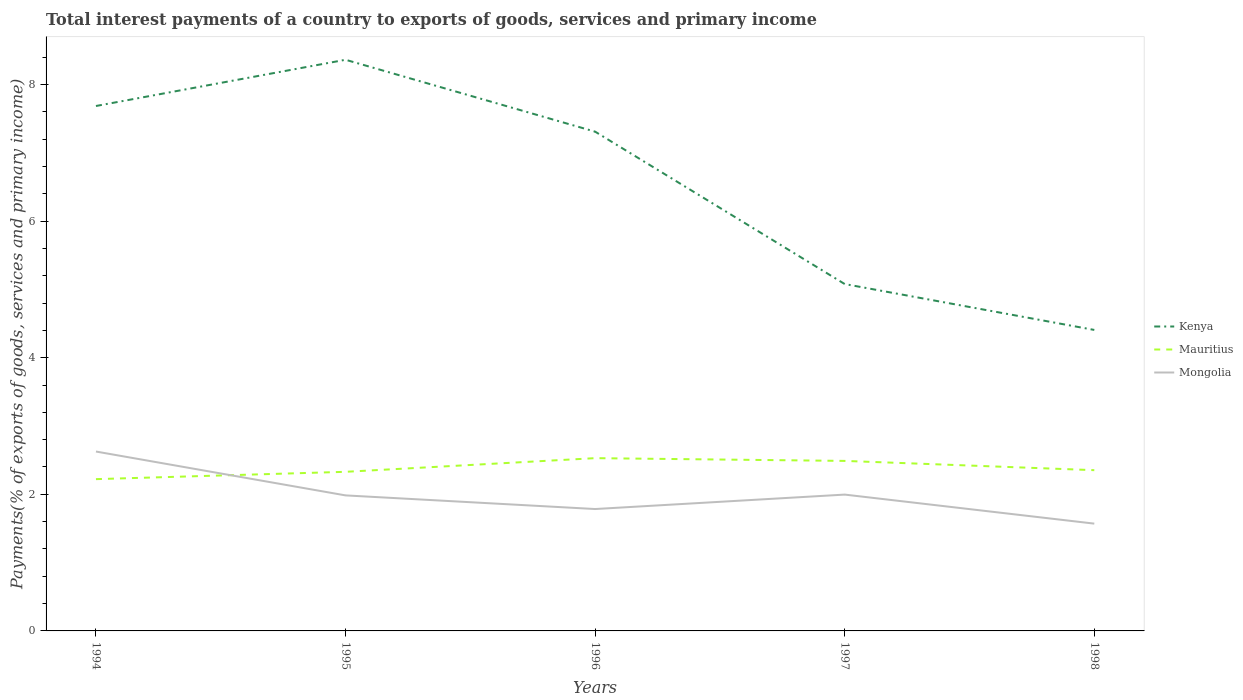How many different coloured lines are there?
Your answer should be very brief. 3. Across all years, what is the maximum total interest payments in Kenya?
Your answer should be very brief. 4.41. In which year was the total interest payments in Mauritius maximum?
Offer a very short reply. 1994. What is the total total interest payments in Kenya in the graph?
Your answer should be compact. 2.61. What is the difference between the highest and the second highest total interest payments in Kenya?
Your response must be concise. 3.96. Is the total interest payments in Kenya strictly greater than the total interest payments in Mongolia over the years?
Your answer should be compact. No. How many years are there in the graph?
Ensure brevity in your answer.  5. What is the difference between two consecutive major ticks on the Y-axis?
Make the answer very short. 2. Does the graph contain any zero values?
Give a very brief answer. No. What is the title of the graph?
Give a very brief answer. Total interest payments of a country to exports of goods, services and primary income. Does "High income" appear as one of the legend labels in the graph?
Provide a succinct answer. No. What is the label or title of the X-axis?
Your answer should be compact. Years. What is the label or title of the Y-axis?
Your response must be concise. Payments(% of exports of goods, services and primary income). What is the Payments(% of exports of goods, services and primary income) in Kenya in 1994?
Offer a terse response. 7.68. What is the Payments(% of exports of goods, services and primary income) in Mauritius in 1994?
Ensure brevity in your answer.  2.22. What is the Payments(% of exports of goods, services and primary income) in Mongolia in 1994?
Ensure brevity in your answer.  2.63. What is the Payments(% of exports of goods, services and primary income) in Kenya in 1995?
Provide a short and direct response. 8.36. What is the Payments(% of exports of goods, services and primary income) in Mauritius in 1995?
Provide a succinct answer. 2.33. What is the Payments(% of exports of goods, services and primary income) of Mongolia in 1995?
Offer a terse response. 1.98. What is the Payments(% of exports of goods, services and primary income) in Kenya in 1996?
Make the answer very short. 7.31. What is the Payments(% of exports of goods, services and primary income) of Mauritius in 1996?
Offer a very short reply. 2.53. What is the Payments(% of exports of goods, services and primary income) in Mongolia in 1996?
Offer a very short reply. 1.78. What is the Payments(% of exports of goods, services and primary income) of Kenya in 1997?
Your response must be concise. 5.08. What is the Payments(% of exports of goods, services and primary income) of Mauritius in 1997?
Ensure brevity in your answer.  2.49. What is the Payments(% of exports of goods, services and primary income) of Mongolia in 1997?
Make the answer very short. 2. What is the Payments(% of exports of goods, services and primary income) of Kenya in 1998?
Your answer should be very brief. 4.41. What is the Payments(% of exports of goods, services and primary income) in Mauritius in 1998?
Your answer should be very brief. 2.35. What is the Payments(% of exports of goods, services and primary income) in Mongolia in 1998?
Provide a succinct answer. 1.57. Across all years, what is the maximum Payments(% of exports of goods, services and primary income) in Kenya?
Give a very brief answer. 8.36. Across all years, what is the maximum Payments(% of exports of goods, services and primary income) in Mauritius?
Your response must be concise. 2.53. Across all years, what is the maximum Payments(% of exports of goods, services and primary income) in Mongolia?
Ensure brevity in your answer.  2.63. Across all years, what is the minimum Payments(% of exports of goods, services and primary income) in Kenya?
Make the answer very short. 4.41. Across all years, what is the minimum Payments(% of exports of goods, services and primary income) of Mauritius?
Provide a short and direct response. 2.22. Across all years, what is the minimum Payments(% of exports of goods, services and primary income) of Mongolia?
Ensure brevity in your answer.  1.57. What is the total Payments(% of exports of goods, services and primary income) in Kenya in the graph?
Your answer should be compact. 32.84. What is the total Payments(% of exports of goods, services and primary income) in Mauritius in the graph?
Your answer should be compact. 11.92. What is the total Payments(% of exports of goods, services and primary income) in Mongolia in the graph?
Give a very brief answer. 9.96. What is the difference between the Payments(% of exports of goods, services and primary income) of Kenya in 1994 and that in 1995?
Give a very brief answer. -0.68. What is the difference between the Payments(% of exports of goods, services and primary income) in Mauritius in 1994 and that in 1995?
Offer a very short reply. -0.11. What is the difference between the Payments(% of exports of goods, services and primary income) of Mongolia in 1994 and that in 1995?
Offer a very short reply. 0.64. What is the difference between the Payments(% of exports of goods, services and primary income) of Kenya in 1994 and that in 1996?
Offer a very short reply. 0.38. What is the difference between the Payments(% of exports of goods, services and primary income) of Mauritius in 1994 and that in 1996?
Your answer should be compact. -0.31. What is the difference between the Payments(% of exports of goods, services and primary income) of Mongolia in 1994 and that in 1996?
Give a very brief answer. 0.84. What is the difference between the Payments(% of exports of goods, services and primary income) in Kenya in 1994 and that in 1997?
Offer a terse response. 2.61. What is the difference between the Payments(% of exports of goods, services and primary income) in Mauritius in 1994 and that in 1997?
Offer a very short reply. -0.27. What is the difference between the Payments(% of exports of goods, services and primary income) of Mongolia in 1994 and that in 1997?
Your answer should be compact. 0.63. What is the difference between the Payments(% of exports of goods, services and primary income) of Kenya in 1994 and that in 1998?
Make the answer very short. 3.28. What is the difference between the Payments(% of exports of goods, services and primary income) of Mauritius in 1994 and that in 1998?
Offer a terse response. -0.13. What is the difference between the Payments(% of exports of goods, services and primary income) of Mongolia in 1994 and that in 1998?
Provide a succinct answer. 1.06. What is the difference between the Payments(% of exports of goods, services and primary income) in Kenya in 1995 and that in 1996?
Provide a short and direct response. 1.05. What is the difference between the Payments(% of exports of goods, services and primary income) of Mauritius in 1995 and that in 1996?
Give a very brief answer. -0.2. What is the difference between the Payments(% of exports of goods, services and primary income) in Mongolia in 1995 and that in 1996?
Offer a very short reply. 0.2. What is the difference between the Payments(% of exports of goods, services and primary income) of Kenya in 1995 and that in 1997?
Your answer should be compact. 3.28. What is the difference between the Payments(% of exports of goods, services and primary income) of Mauritius in 1995 and that in 1997?
Your answer should be very brief. -0.16. What is the difference between the Payments(% of exports of goods, services and primary income) of Mongolia in 1995 and that in 1997?
Your answer should be compact. -0.01. What is the difference between the Payments(% of exports of goods, services and primary income) of Kenya in 1995 and that in 1998?
Your response must be concise. 3.96. What is the difference between the Payments(% of exports of goods, services and primary income) in Mauritius in 1995 and that in 1998?
Your answer should be very brief. -0.02. What is the difference between the Payments(% of exports of goods, services and primary income) in Mongolia in 1995 and that in 1998?
Keep it short and to the point. 0.41. What is the difference between the Payments(% of exports of goods, services and primary income) of Kenya in 1996 and that in 1997?
Your answer should be very brief. 2.23. What is the difference between the Payments(% of exports of goods, services and primary income) of Mauritius in 1996 and that in 1997?
Make the answer very short. 0.04. What is the difference between the Payments(% of exports of goods, services and primary income) of Mongolia in 1996 and that in 1997?
Provide a succinct answer. -0.21. What is the difference between the Payments(% of exports of goods, services and primary income) in Kenya in 1996 and that in 1998?
Your answer should be compact. 2.9. What is the difference between the Payments(% of exports of goods, services and primary income) in Mauritius in 1996 and that in 1998?
Give a very brief answer. 0.18. What is the difference between the Payments(% of exports of goods, services and primary income) of Mongolia in 1996 and that in 1998?
Your answer should be very brief. 0.21. What is the difference between the Payments(% of exports of goods, services and primary income) of Kenya in 1997 and that in 1998?
Offer a very short reply. 0.67. What is the difference between the Payments(% of exports of goods, services and primary income) in Mauritius in 1997 and that in 1998?
Offer a terse response. 0.14. What is the difference between the Payments(% of exports of goods, services and primary income) of Mongolia in 1997 and that in 1998?
Your answer should be very brief. 0.43. What is the difference between the Payments(% of exports of goods, services and primary income) of Kenya in 1994 and the Payments(% of exports of goods, services and primary income) of Mauritius in 1995?
Offer a very short reply. 5.36. What is the difference between the Payments(% of exports of goods, services and primary income) of Kenya in 1994 and the Payments(% of exports of goods, services and primary income) of Mongolia in 1995?
Give a very brief answer. 5.7. What is the difference between the Payments(% of exports of goods, services and primary income) in Mauritius in 1994 and the Payments(% of exports of goods, services and primary income) in Mongolia in 1995?
Your answer should be compact. 0.24. What is the difference between the Payments(% of exports of goods, services and primary income) of Kenya in 1994 and the Payments(% of exports of goods, services and primary income) of Mauritius in 1996?
Ensure brevity in your answer.  5.16. What is the difference between the Payments(% of exports of goods, services and primary income) in Kenya in 1994 and the Payments(% of exports of goods, services and primary income) in Mongolia in 1996?
Keep it short and to the point. 5.9. What is the difference between the Payments(% of exports of goods, services and primary income) of Mauritius in 1994 and the Payments(% of exports of goods, services and primary income) of Mongolia in 1996?
Make the answer very short. 0.44. What is the difference between the Payments(% of exports of goods, services and primary income) of Kenya in 1994 and the Payments(% of exports of goods, services and primary income) of Mauritius in 1997?
Give a very brief answer. 5.2. What is the difference between the Payments(% of exports of goods, services and primary income) of Kenya in 1994 and the Payments(% of exports of goods, services and primary income) of Mongolia in 1997?
Ensure brevity in your answer.  5.69. What is the difference between the Payments(% of exports of goods, services and primary income) of Mauritius in 1994 and the Payments(% of exports of goods, services and primary income) of Mongolia in 1997?
Provide a succinct answer. 0.23. What is the difference between the Payments(% of exports of goods, services and primary income) in Kenya in 1994 and the Payments(% of exports of goods, services and primary income) in Mauritius in 1998?
Your response must be concise. 5.33. What is the difference between the Payments(% of exports of goods, services and primary income) in Kenya in 1994 and the Payments(% of exports of goods, services and primary income) in Mongolia in 1998?
Keep it short and to the point. 6.11. What is the difference between the Payments(% of exports of goods, services and primary income) of Mauritius in 1994 and the Payments(% of exports of goods, services and primary income) of Mongolia in 1998?
Ensure brevity in your answer.  0.65. What is the difference between the Payments(% of exports of goods, services and primary income) of Kenya in 1995 and the Payments(% of exports of goods, services and primary income) of Mauritius in 1996?
Offer a very short reply. 5.83. What is the difference between the Payments(% of exports of goods, services and primary income) in Kenya in 1995 and the Payments(% of exports of goods, services and primary income) in Mongolia in 1996?
Give a very brief answer. 6.58. What is the difference between the Payments(% of exports of goods, services and primary income) of Mauritius in 1995 and the Payments(% of exports of goods, services and primary income) of Mongolia in 1996?
Your answer should be compact. 0.55. What is the difference between the Payments(% of exports of goods, services and primary income) in Kenya in 1995 and the Payments(% of exports of goods, services and primary income) in Mauritius in 1997?
Your response must be concise. 5.87. What is the difference between the Payments(% of exports of goods, services and primary income) in Kenya in 1995 and the Payments(% of exports of goods, services and primary income) in Mongolia in 1997?
Your response must be concise. 6.37. What is the difference between the Payments(% of exports of goods, services and primary income) in Mauritius in 1995 and the Payments(% of exports of goods, services and primary income) in Mongolia in 1997?
Provide a succinct answer. 0.33. What is the difference between the Payments(% of exports of goods, services and primary income) in Kenya in 1995 and the Payments(% of exports of goods, services and primary income) in Mauritius in 1998?
Make the answer very short. 6.01. What is the difference between the Payments(% of exports of goods, services and primary income) of Kenya in 1995 and the Payments(% of exports of goods, services and primary income) of Mongolia in 1998?
Provide a short and direct response. 6.79. What is the difference between the Payments(% of exports of goods, services and primary income) in Mauritius in 1995 and the Payments(% of exports of goods, services and primary income) in Mongolia in 1998?
Offer a very short reply. 0.76. What is the difference between the Payments(% of exports of goods, services and primary income) of Kenya in 1996 and the Payments(% of exports of goods, services and primary income) of Mauritius in 1997?
Offer a terse response. 4.82. What is the difference between the Payments(% of exports of goods, services and primary income) of Kenya in 1996 and the Payments(% of exports of goods, services and primary income) of Mongolia in 1997?
Offer a very short reply. 5.31. What is the difference between the Payments(% of exports of goods, services and primary income) in Mauritius in 1996 and the Payments(% of exports of goods, services and primary income) in Mongolia in 1997?
Ensure brevity in your answer.  0.53. What is the difference between the Payments(% of exports of goods, services and primary income) in Kenya in 1996 and the Payments(% of exports of goods, services and primary income) in Mauritius in 1998?
Give a very brief answer. 4.96. What is the difference between the Payments(% of exports of goods, services and primary income) of Kenya in 1996 and the Payments(% of exports of goods, services and primary income) of Mongolia in 1998?
Your answer should be compact. 5.74. What is the difference between the Payments(% of exports of goods, services and primary income) in Mauritius in 1996 and the Payments(% of exports of goods, services and primary income) in Mongolia in 1998?
Provide a succinct answer. 0.96. What is the difference between the Payments(% of exports of goods, services and primary income) in Kenya in 1997 and the Payments(% of exports of goods, services and primary income) in Mauritius in 1998?
Your answer should be compact. 2.73. What is the difference between the Payments(% of exports of goods, services and primary income) of Kenya in 1997 and the Payments(% of exports of goods, services and primary income) of Mongolia in 1998?
Offer a very short reply. 3.51. What is the difference between the Payments(% of exports of goods, services and primary income) of Mauritius in 1997 and the Payments(% of exports of goods, services and primary income) of Mongolia in 1998?
Your answer should be very brief. 0.92. What is the average Payments(% of exports of goods, services and primary income) in Kenya per year?
Your answer should be very brief. 6.57. What is the average Payments(% of exports of goods, services and primary income) in Mauritius per year?
Your response must be concise. 2.38. What is the average Payments(% of exports of goods, services and primary income) of Mongolia per year?
Your answer should be compact. 1.99. In the year 1994, what is the difference between the Payments(% of exports of goods, services and primary income) of Kenya and Payments(% of exports of goods, services and primary income) of Mauritius?
Keep it short and to the point. 5.46. In the year 1994, what is the difference between the Payments(% of exports of goods, services and primary income) in Kenya and Payments(% of exports of goods, services and primary income) in Mongolia?
Give a very brief answer. 5.06. In the year 1994, what is the difference between the Payments(% of exports of goods, services and primary income) of Mauritius and Payments(% of exports of goods, services and primary income) of Mongolia?
Provide a succinct answer. -0.4. In the year 1995, what is the difference between the Payments(% of exports of goods, services and primary income) of Kenya and Payments(% of exports of goods, services and primary income) of Mauritius?
Keep it short and to the point. 6.03. In the year 1995, what is the difference between the Payments(% of exports of goods, services and primary income) of Kenya and Payments(% of exports of goods, services and primary income) of Mongolia?
Your answer should be very brief. 6.38. In the year 1995, what is the difference between the Payments(% of exports of goods, services and primary income) of Mauritius and Payments(% of exports of goods, services and primary income) of Mongolia?
Offer a very short reply. 0.35. In the year 1996, what is the difference between the Payments(% of exports of goods, services and primary income) in Kenya and Payments(% of exports of goods, services and primary income) in Mauritius?
Provide a short and direct response. 4.78. In the year 1996, what is the difference between the Payments(% of exports of goods, services and primary income) in Kenya and Payments(% of exports of goods, services and primary income) in Mongolia?
Keep it short and to the point. 5.52. In the year 1996, what is the difference between the Payments(% of exports of goods, services and primary income) of Mauritius and Payments(% of exports of goods, services and primary income) of Mongolia?
Your response must be concise. 0.74. In the year 1997, what is the difference between the Payments(% of exports of goods, services and primary income) of Kenya and Payments(% of exports of goods, services and primary income) of Mauritius?
Keep it short and to the point. 2.59. In the year 1997, what is the difference between the Payments(% of exports of goods, services and primary income) in Kenya and Payments(% of exports of goods, services and primary income) in Mongolia?
Keep it short and to the point. 3.08. In the year 1997, what is the difference between the Payments(% of exports of goods, services and primary income) in Mauritius and Payments(% of exports of goods, services and primary income) in Mongolia?
Offer a very short reply. 0.49. In the year 1998, what is the difference between the Payments(% of exports of goods, services and primary income) of Kenya and Payments(% of exports of goods, services and primary income) of Mauritius?
Provide a succinct answer. 2.05. In the year 1998, what is the difference between the Payments(% of exports of goods, services and primary income) in Kenya and Payments(% of exports of goods, services and primary income) in Mongolia?
Your answer should be very brief. 2.84. In the year 1998, what is the difference between the Payments(% of exports of goods, services and primary income) in Mauritius and Payments(% of exports of goods, services and primary income) in Mongolia?
Your answer should be very brief. 0.78. What is the ratio of the Payments(% of exports of goods, services and primary income) in Kenya in 1994 to that in 1995?
Offer a very short reply. 0.92. What is the ratio of the Payments(% of exports of goods, services and primary income) in Mauritius in 1994 to that in 1995?
Offer a very short reply. 0.95. What is the ratio of the Payments(% of exports of goods, services and primary income) in Mongolia in 1994 to that in 1995?
Keep it short and to the point. 1.32. What is the ratio of the Payments(% of exports of goods, services and primary income) in Kenya in 1994 to that in 1996?
Your response must be concise. 1.05. What is the ratio of the Payments(% of exports of goods, services and primary income) of Mauritius in 1994 to that in 1996?
Provide a short and direct response. 0.88. What is the ratio of the Payments(% of exports of goods, services and primary income) in Mongolia in 1994 to that in 1996?
Your answer should be compact. 1.47. What is the ratio of the Payments(% of exports of goods, services and primary income) in Kenya in 1994 to that in 1997?
Make the answer very short. 1.51. What is the ratio of the Payments(% of exports of goods, services and primary income) in Mauritius in 1994 to that in 1997?
Make the answer very short. 0.89. What is the ratio of the Payments(% of exports of goods, services and primary income) in Mongolia in 1994 to that in 1997?
Keep it short and to the point. 1.32. What is the ratio of the Payments(% of exports of goods, services and primary income) in Kenya in 1994 to that in 1998?
Your response must be concise. 1.74. What is the ratio of the Payments(% of exports of goods, services and primary income) of Mauritius in 1994 to that in 1998?
Your answer should be very brief. 0.94. What is the ratio of the Payments(% of exports of goods, services and primary income) in Mongolia in 1994 to that in 1998?
Offer a very short reply. 1.67. What is the ratio of the Payments(% of exports of goods, services and primary income) in Kenya in 1995 to that in 1996?
Offer a terse response. 1.14. What is the ratio of the Payments(% of exports of goods, services and primary income) of Mauritius in 1995 to that in 1996?
Ensure brevity in your answer.  0.92. What is the ratio of the Payments(% of exports of goods, services and primary income) in Mongolia in 1995 to that in 1996?
Give a very brief answer. 1.11. What is the ratio of the Payments(% of exports of goods, services and primary income) of Kenya in 1995 to that in 1997?
Give a very brief answer. 1.65. What is the ratio of the Payments(% of exports of goods, services and primary income) of Mauritius in 1995 to that in 1997?
Offer a terse response. 0.94. What is the ratio of the Payments(% of exports of goods, services and primary income) in Mongolia in 1995 to that in 1997?
Your answer should be very brief. 0.99. What is the ratio of the Payments(% of exports of goods, services and primary income) of Kenya in 1995 to that in 1998?
Make the answer very short. 1.9. What is the ratio of the Payments(% of exports of goods, services and primary income) of Mongolia in 1995 to that in 1998?
Provide a succinct answer. 1.26. What is the ratio of the Payments(% of exports of goods, services and primary income) of Kenya in 1996 to that in 1997?
Your answer should be compact. 1.44. What is the ratio of the Payments(% of exports of goods, services and primary income) in Mauritius in 1996 to that in 1997?
Ensure brevity in your answer.  1.02. What is the ratio of the Payments(% of exports of goods, services and primary income) of Mongolia in 1996 to that in 1997?
Provide a succinct answer. 0.89. What is the ratio of the Payments(% of exports of goods, services and primary income) in Kenya in 1996 to that in 1998?
Your response must be concise. 1.66. What is the ratio of the Payments(% of exports of goods, services and primary income) of Mauritius in 1996 to that in 1998?
Provide a short and direct response. 1.07. What is the ratio of the Payments(% of exports of goods, services and primary income) in Mongolia in 1996 to that in 1998?
Keep it short and to the point. 1.14. What is the ratio of the Payments(% of exports of goods, services and primary income) of Kenya in 1997 to that in 1998?
Ensure brevity in your answer.  1.15. What is the ratio of the Payments(% of exports of goods, services and primary income) in Mauritius in 1997 to that in 1998?
Offer a terse response. 1.06. What is the ratio of the Payments(% of exports of goods, services and primary income) of Mongolia in 1997 to that in 1998?
Provide a short and direct response. 1.27. What is the difference between the highest and the second highest Payments(% of exports of goods, services and primary income) of Kenya?
Your answer should be compact. 0.68. What is the difference between the highest and the second highest Payments(% of exports of goods, services and primary income) of Mauritius?
Give a very brief answer. 0.04. What is the difference between the highest and the second highest Payments(% of exports of goods, services and primary income) in Mongolia?
Keep it short and to the point. 0.63. What is the difference between the highest and the lowest Payments(% of exports of goods, services and primary income) of Kenya?
Make the answer very short. 3.96. What is the difference between the highest and the lowest Payments(% of exports of goods, services and primary income) in Mauritius?
Offer a terse response. 0.31. What is the difference between the highest and the lowest Payments(% of exports of goods, services and primary income) in Mongolia?
Offer a terse response. 1.06. 